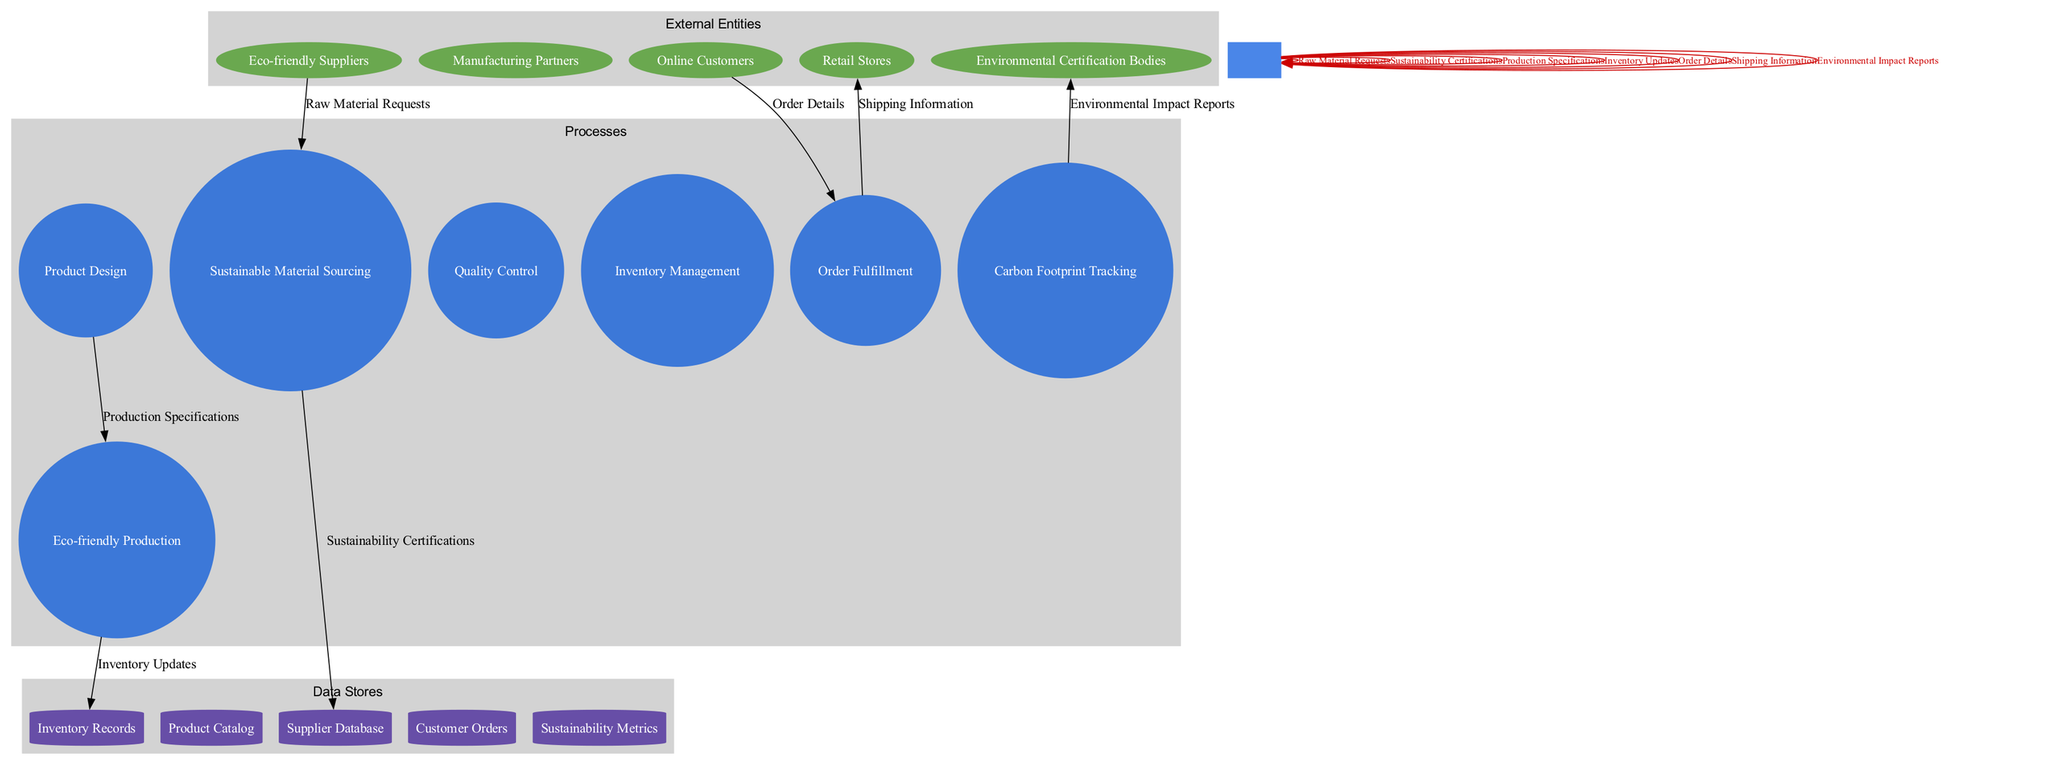What are the external entities involved in the diagram? The external entities are listed directly within the diagram. They include Eco-friendly Suppliers, Manufacturing Partners, Retail Stores, Online Customers, and Environmental Certification Bodies.
Answer: Eco-friendly Suppliers, Manufacturing Partners, Retail Stores, Online Customers, Environmental Certification Bodies How many processes are illustrated in the diagram? The diagram contains a section dedicated to processes. Counting the listed processes reveals there are seven: Sustainable Material Sourcing, Product Design, Eco-friendly Production, Quality Control, Inventory Management, Order Fulfillment, and Carbon Footprint Tracking.
Answer: Seven Which process is responsible for ensuring the quality of products? The process "Quality Control" explicitly denotes the function of ensuring that the products meet set standards and specifications, which is a critical part of the supply chain.
Answer: Quality Control What type of data store is used for maintaining customer orders? The label "Customer Orders" indicates that it is a data store specifically for tracking information related to orders placed by customers within the supply chain.
Answer: Cylinder How does sustainable material sourcing relate to the suppliers? The arrow labeled "Raw Material Requests" shows that Eco-friendly Suppliers supply the necessary materials through Sustainable Material Sourcing, which creates a direct relationship between the two elements.
Answer: Supply relationship What data flow connects online customers to the order fulfillment process? The "Order Details" data flow described in the diagram shows the direct connection between the Online Customers and the Order Fulfillment process, indicating the transfer of order information.
Answer: Order Details Which data store collects metrics on sustainability? The data store labeled "Sustainability Metrics" directly indicates that it gathers and stores information related to sustainability practices within the organization.
Answer: Sustainability Metrics How many data flows are depicted in the diagram? By examining the data flow section, there are six labeled flows: Raw Material Requests, Sustainability Certifications, Production Specifications, Inventory Updates, Order Details, and Shipping Information. Counting these gives a total.
Answer: Six 